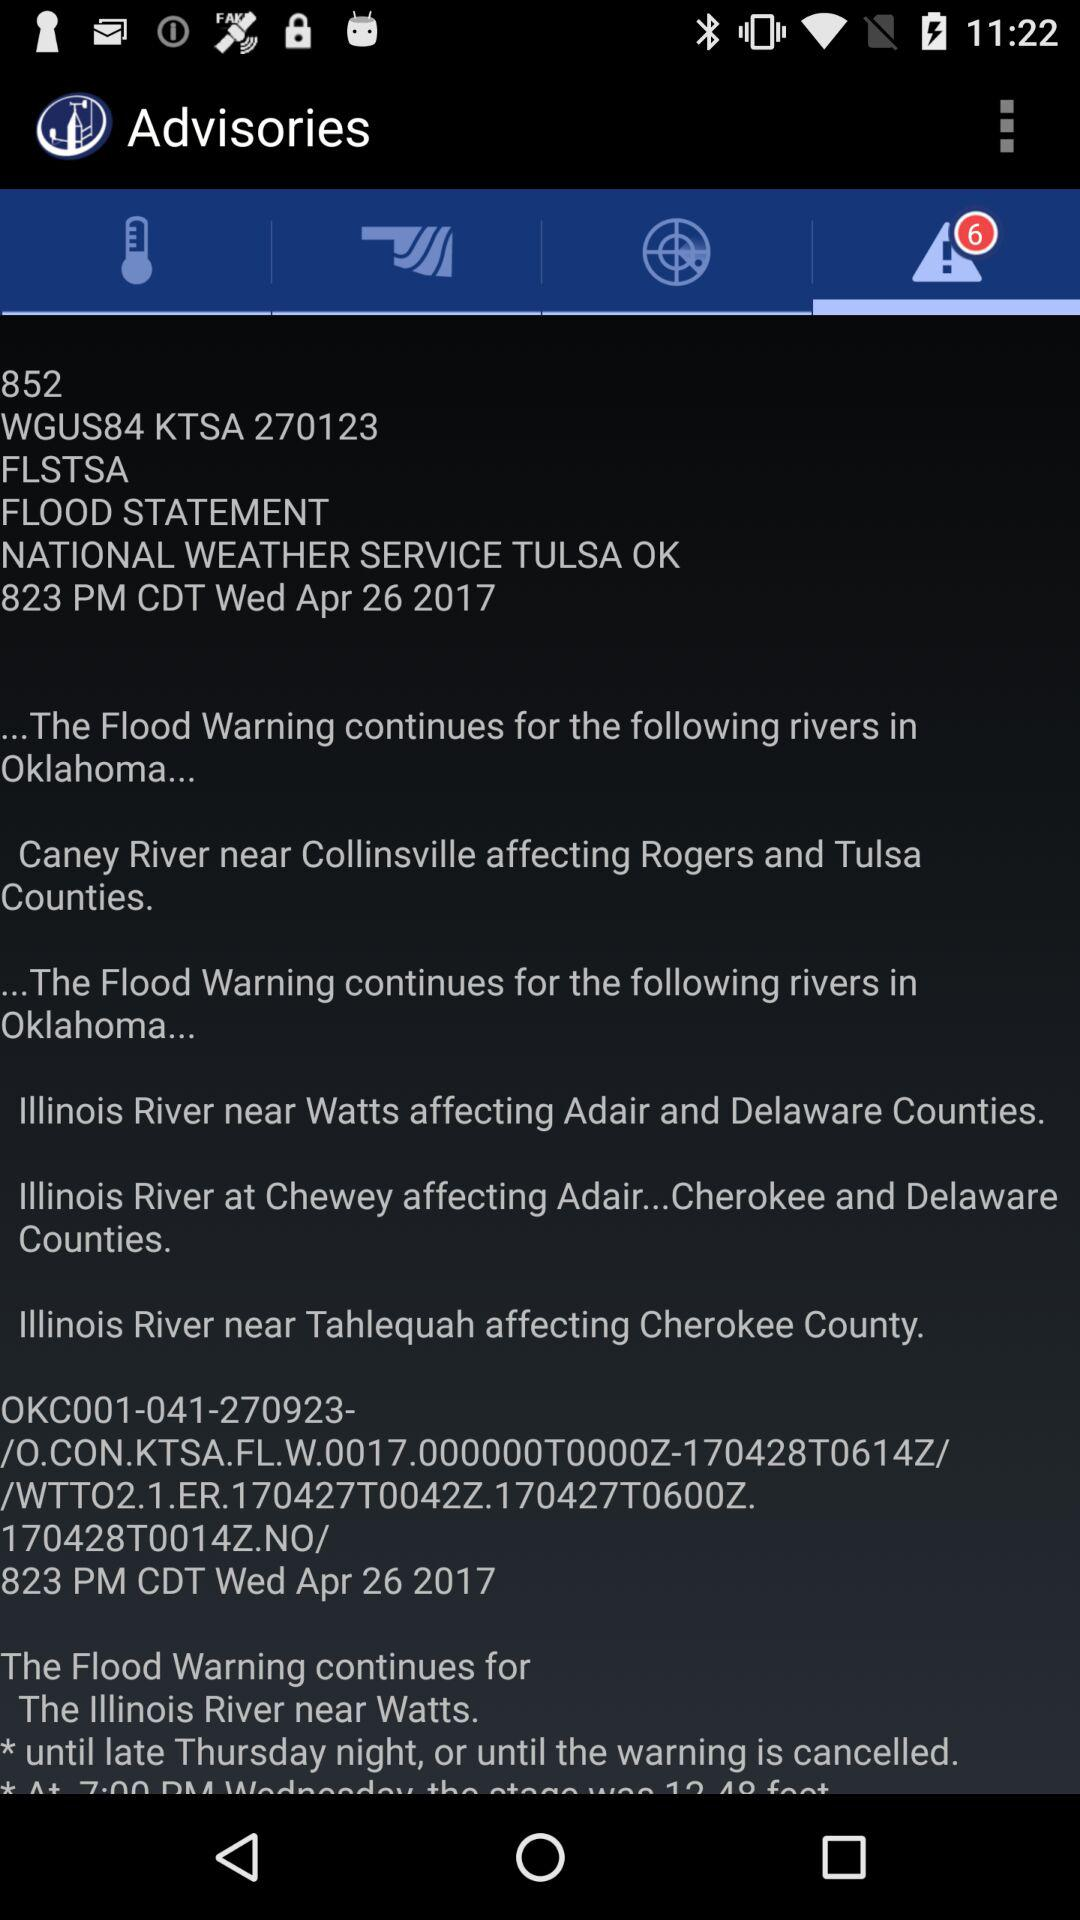What's the number of alert notifications? The number of alert notifications is 6. 